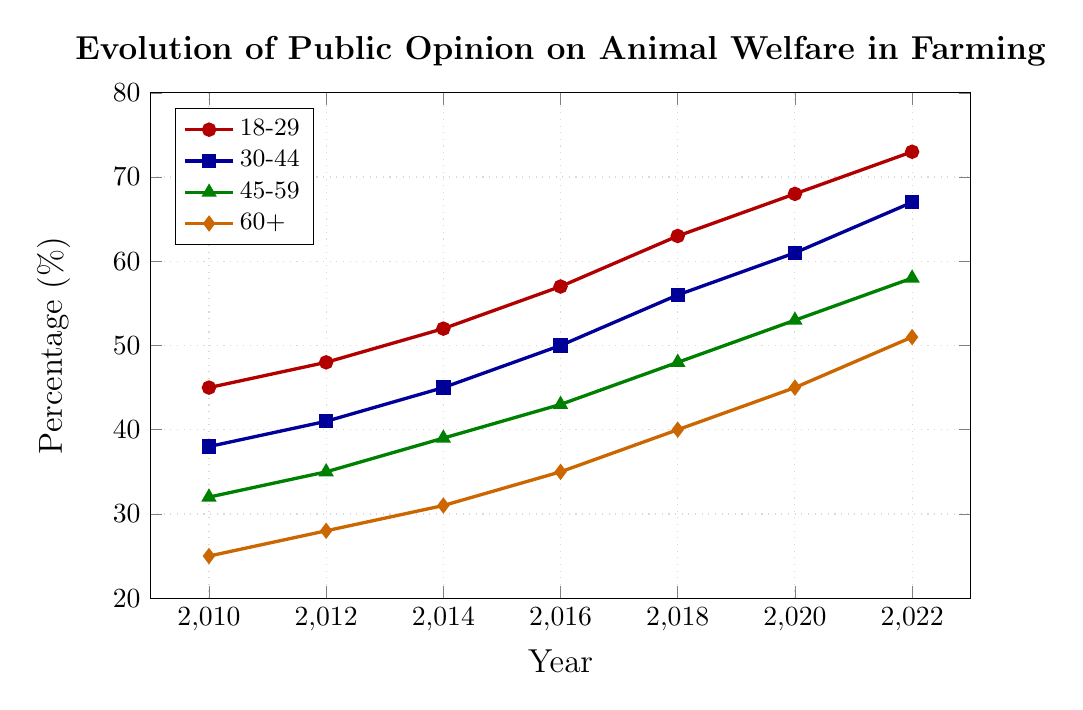Which age group shows the highest increase in percentage from 2010 to 2022? To find the highest increase, we calculate the difference between the 2022 and 2010 values for each age group. For 18-29, the difference is 73-45=28. For 30-44, it's 67-38=29. For 45-59, it's 58-32=26. For 60+, it's 51-25=26. The age group 30-44 shows the highest increase with a difference of 29.
Answer: 30-44 Which age group had the lowest percentage in 2014? To answer this, we check the values in 2014 for all age groups. 18-29 has 52%, 30-44 has 45%, 45-59 has 39%, and 60+ has 31%. The lowest percentage in 2014 is in the 60+ age group with 31%.
Answer: 60+ What is the average percentage for the 45-59 age group over all the years shown? Average percentage is calculated by summing all percentages for 45-59 and dividing by the number of data points. (32+35+39+43+48+53+58) / 7 = 43.43%.
Answer: 43.43% How does the percentage for the 18-29 age group in 2022 compare to the 30-44 age group in 2016? The 18-29 age group in 2022 is 73%, and the 30-44 age group in 2016 is 50%. The 18-29 age group in 2022 has a higher percentage by 23%.
Answer: Higher by 23% Which year shows the smallest percentage difference between the 18-29 and 60+ age groups? Calculate the difference for each year: 2010 (45-25=20), 2012 (48-28=20), 2014 (52-31=21), 2016 (57-35=22), 2018 (63-40=23), 2020 (68-45=23), and 2022 (73-51=22). The smallest differences are in 2010 and 2012 with a difference of 20.
Answer: 2010 and 2012 What is the trend in the percentage for the 60+ age group from 2010 to 2022? To find the trend, we observe the percentage values for the 60+ age group from 2010 to 2022: 25, 28, 31, 35, 40, 45, 51. The percentages continuously increase over these years, indicating an upward trend.
Answer: Upward trend By how much did the opinion percentage for the 45-59 age group change between 2016 and 2020? The percentage for the 45-59 group in 2016 is 43% and in 2020 is 53%. The change is 53 - 43 = 10%.
Answer: 10% How do the trends of the 18-29 and 60+ age groups compare between 2010 and 2022? Both the 18-29 and 60+ age groups show an increasing trend in their percentages over the years from 2010 to 2022. However, the 18-29 age group has a steeper increase compared to the more gradual increase in the 60+ group.
Answer: Both increasing, 18-29 steeper 